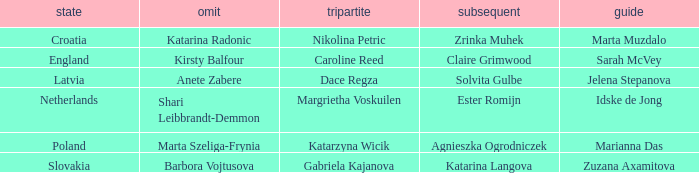What is the name of the third who has Barbora Vojtusova as Skip? Gabriela Kajanova. 